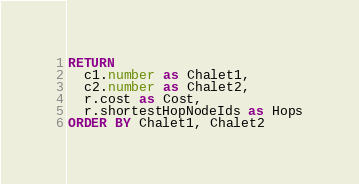<code> <loc_0><loc_0><loc_500><loc_500><_SQL_>RETURN
  c1.number as Chalet1,
  c2.number as Chalet2,
  r.cost as Cost,
  r.shortestHopNodeIds as Hops
ORDER BY Chalet1, Chalet2</code> 